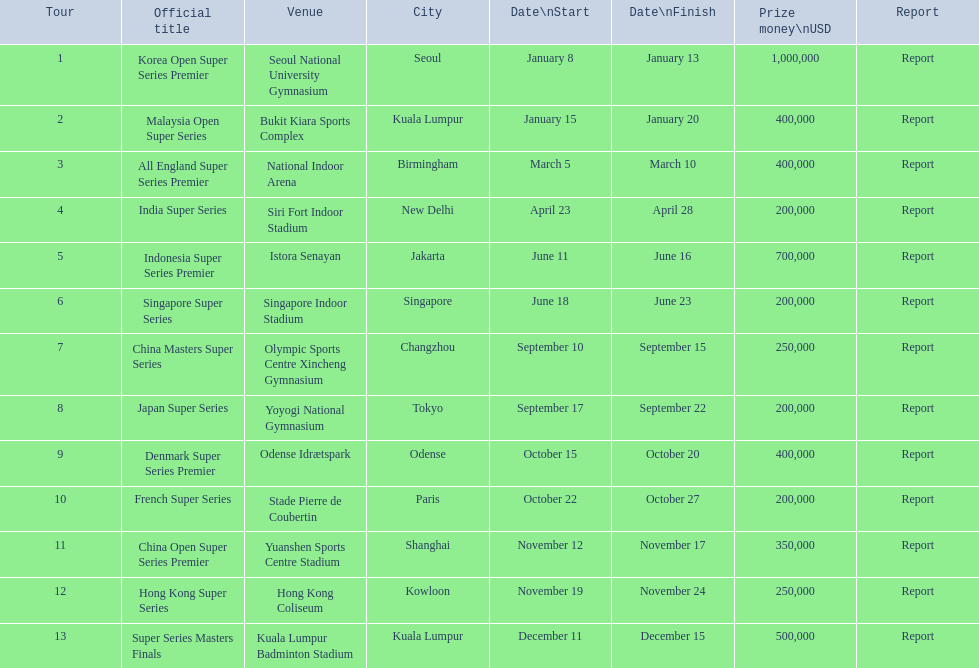What is the complete list of tours? Korea Open Super Series Premier, Malaysia Open Super Series, All England Super Series Premier, India Super Series, Indonesia Super Series Premier, Singapore Super Series, China Masters Super Series, Japan Super Series, Denmark Super Series Premier, French Super Series, China Open Super Series Premier, Hong Kong Super Series, Super Series Masters Finals. When did each tour begin? January 8, January 15, March 5, April 23, June 11, June 18, September 10, September 17, October 15, October 22, November 12, November 19, December 11. Among them, which took place in december? December 11. Which specific tour commenced on that date? Super Series Masters Finals. 